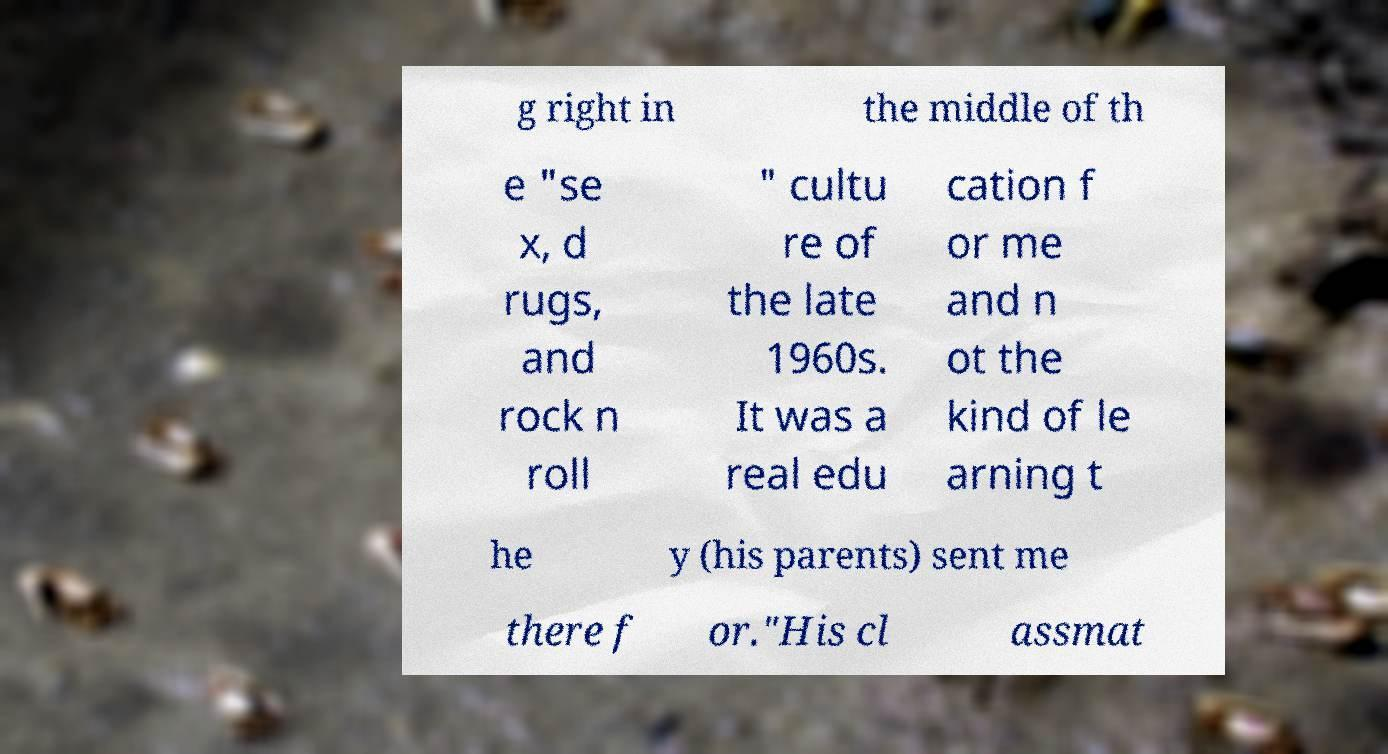For documentation purposes, I need the text within this image transcribed. Could you provide that? g right in the middle of th e "se x, d rugs, and rock n roll " cultu re of the late 1960s. It was a real edu cation f or me and n ot the kind of le arning t he y (his parents) sent me there f or."His cl assmat 